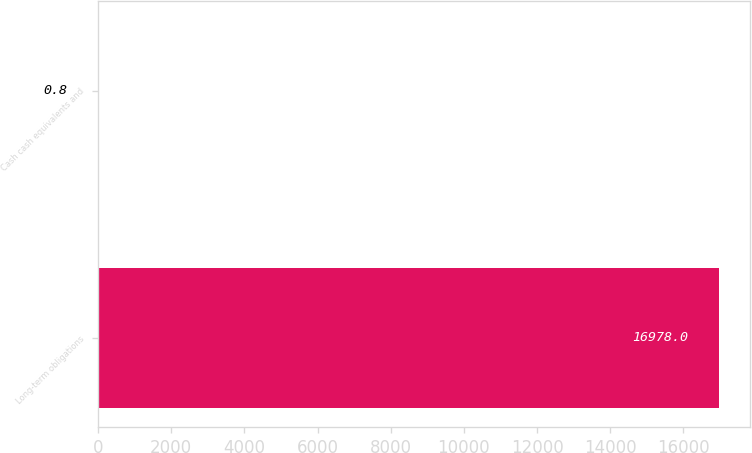Convert chart to OTSL. <chart><loc_0><loc_0><loc_500><loc_500><bar_chart><fcel>Long-term obligations<fcel>Cash cash equivalents and<nl><fcel>16978<fcel>0.8<nl></chart> 